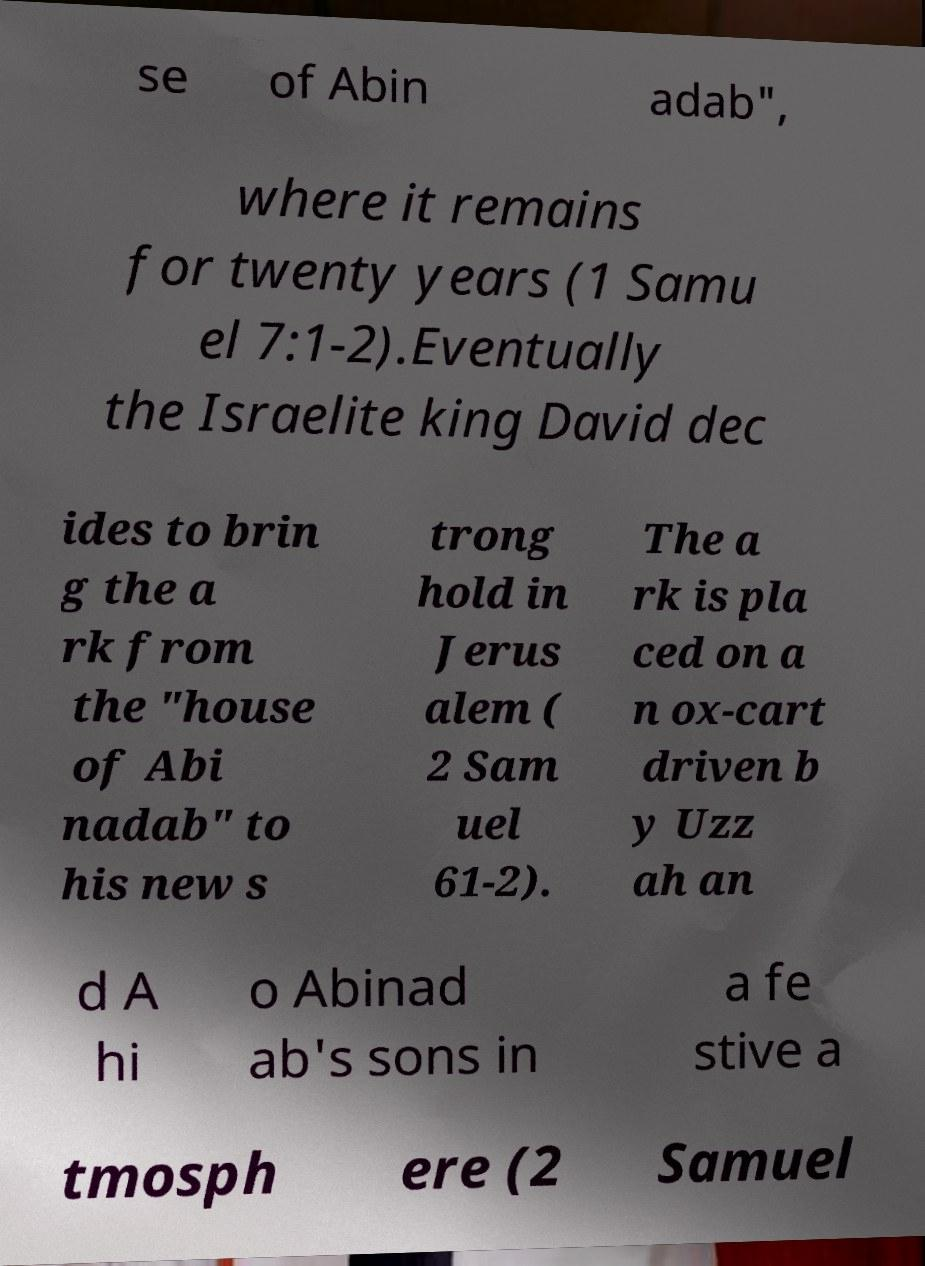I need the written content from this picture converted into text. Can you do that? se of Abin adab", where it remains for twenty years (1 Samu el 7:1-2).Eventually the Israelite king David dec ides to brin g the a rk from the "house of Abi nadab" to his new s trong hold in Jerus alem ( 2 Sam uel 61-2). The a rk is pla ced on a n ox-cart driven b y Uzz ah an d A hi o Abinad ab's sons in a fe stive a tmosph ere (2 Samuel 